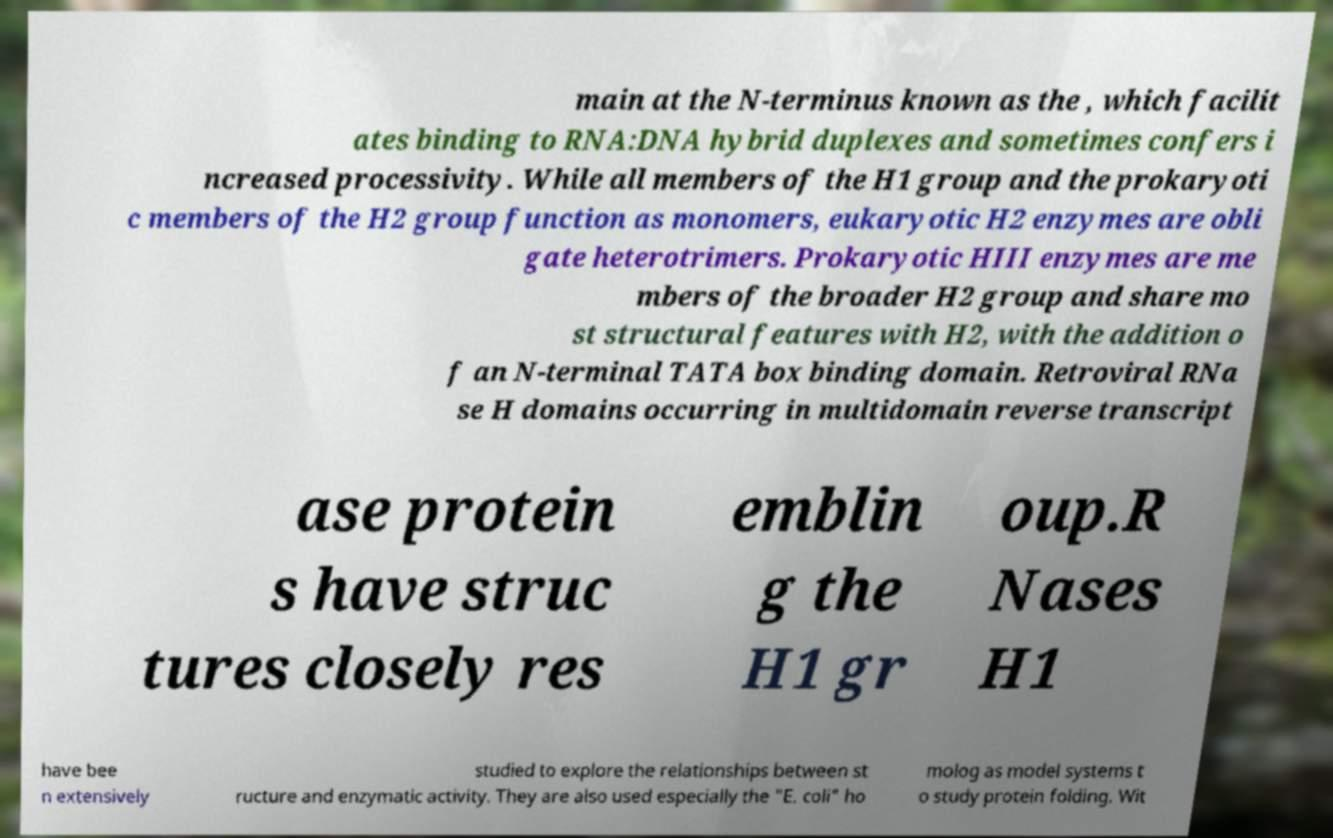Please identify and transcribe the text found in this image. main at the N-terminus known as the , which facilit ates binding to RNA:DNA hybrid duplexes and sometimes confers i ncreased processivity. While all members of the H1 group and the prokaryoti c members of the H2 group function as monomers, eukaryotic H2 enzymes are obli gate heterotrimers. Prokaryotic HIII enzymes are me mbers of the broader H2 group and share mo st structural features with H2, with the addition o f an N-terminal TATA box binding domain. Retroviral RNa se H domains occurring in multidomain reverse transcript ase protein s have struc tures closely res emblin g the H1 gr oup.R Nases H1 have bee n extensively studied to explore the relationships between st ructure and enzymatic activity. They are also used especially the "E. coli" ho molog as model systems t o study protein folding. Wit 